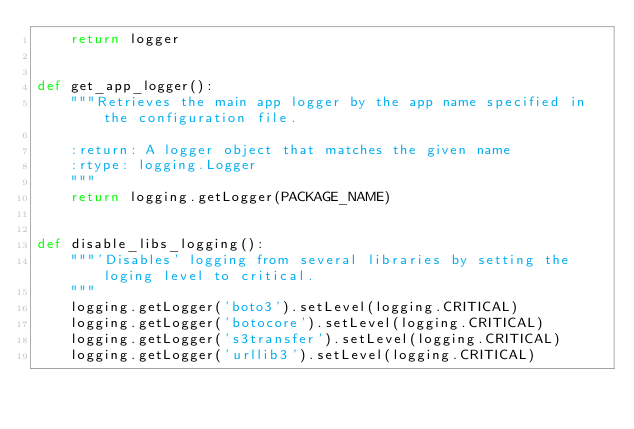<code> <loc_0><loc_0><loc_500><loc_500><_Python_>    return logger


def get_app_logger():
    """Retrieves the main app logger by the app name specified in the configuration file.

    :return: A logger object that matches the given name
    :rtype: logging.Logger
    """
    return logging.getLogger(PACKAGE_NAME)


def disable_libs_logging():
    """'Disables' logging from several libraries by setting the loging level to critical.
    """
    logging.getLogger('boto3').setLevel(logging.CRITICAL)
    logging.getLogger('botocore').setLevel(logging.CRITICAL)
    logging.getLogger('s3transfer').setLevel(logging.CRITICAL)
    logging.getLogger('urllib3').setLevel(logging.CRITICAL)
</code> 